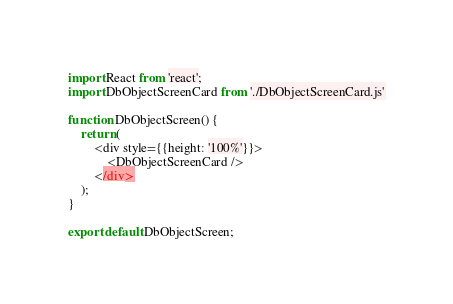Convert code to text. <code><loc_0><loc_0><loc_500><loc_500><_JavaScript_>import React from 'react';
import DbObjectScreenCard from './DbObjectScreenCard.js'

function DbObjectScreen() {
    return (
        <div style={{height: '100%'}}>
			<DbObjectScreenCard />
        </div>
    );
}

export default DbObjectScreen;
</code> 